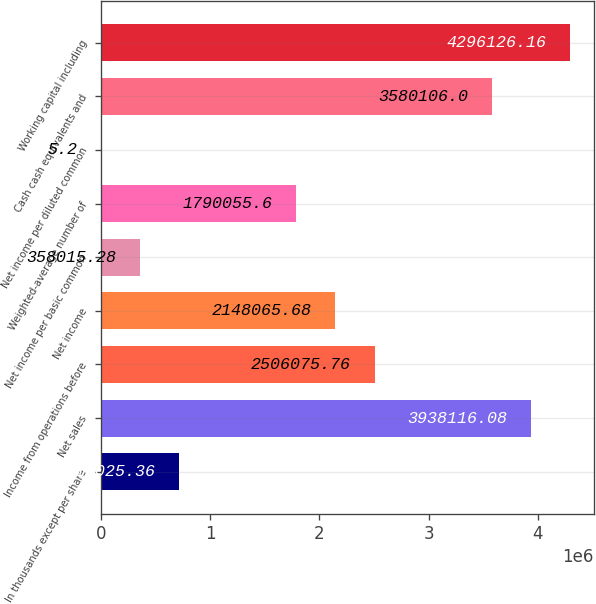Convert chart. <chart><loc_0><loc_0><loc_500><loc_500><bar_chart><fcel>In thousands except per share<fcel>Net sales<fcel>Income from operations before<fcel>Net income<fcel>Net income per basic common<fcel>Weighted-average number of<fcel>Net income per diluted common<fcel>Cash cash equivalents and<fcel>Working capital including<nl><fcel>716025<fcel>3.93812e+06<fcel>2.50608e+06<fcel>2.14807e+06<fcel>358015<fcel>1.79006e+06<fcel>5.2<fcel>3.58011e+06<fcel>4.29613e+06<nl></chart> 